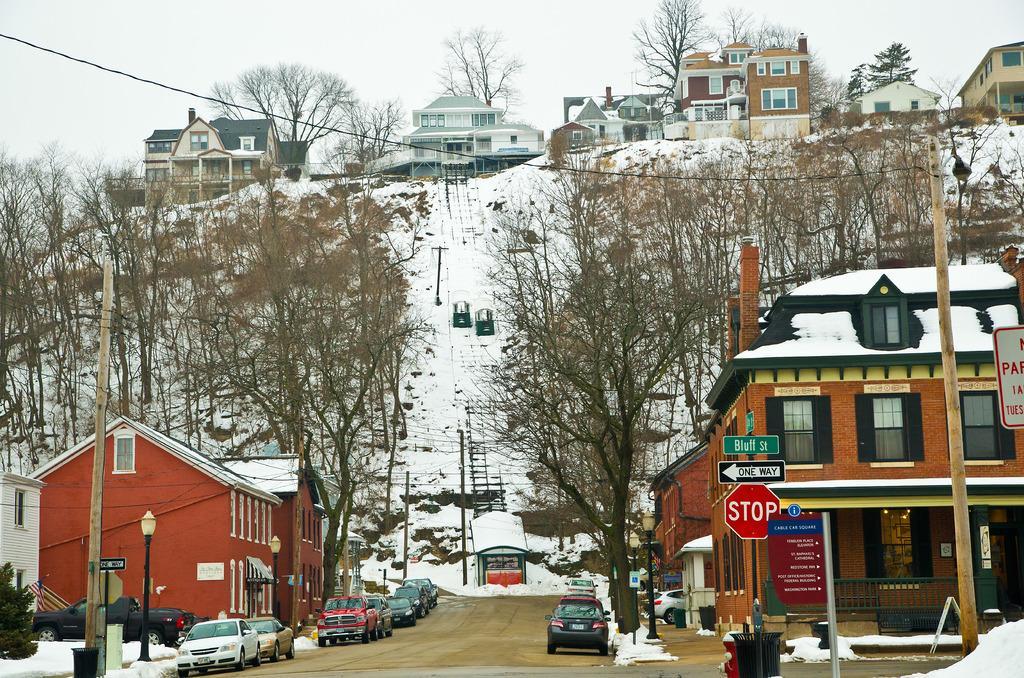How would you summarize this image in a sentence or two? There is a road at the center of the image. There are cars. There are trees. There are buildings at the both sides of the image. There is snow. 